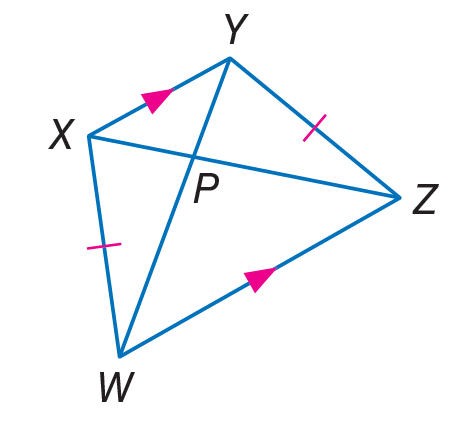Question: Find P W, if X Z = 18 and P Y = 3.
Choices:
A. 3
B. 6
C. 15
D. 18
Answer with the letter. Answer: C 